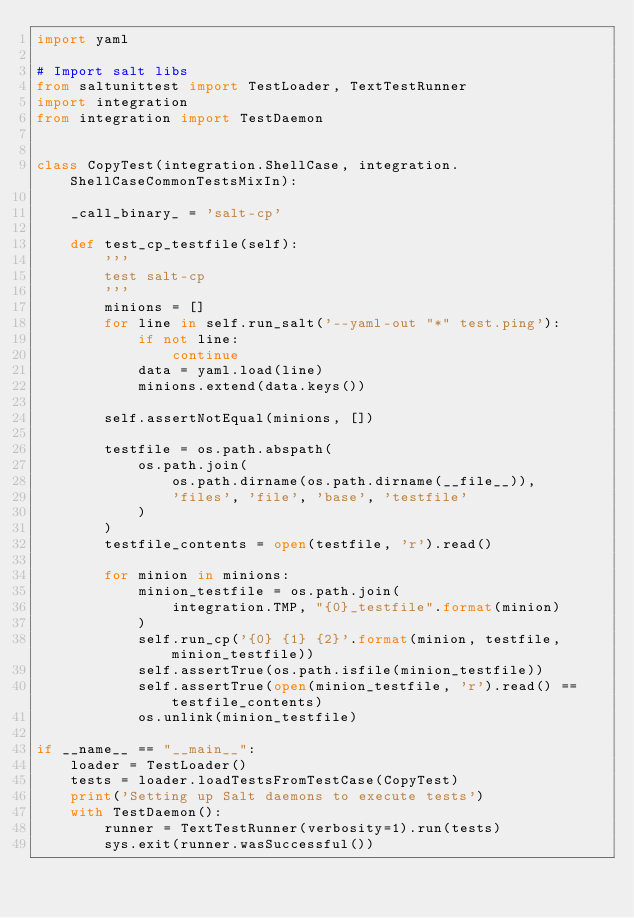<code> <loc_0><loc_0><loc_500><loc_500><_Python_>import yaml

# Import salt libs
from saltunittest import TestLoader, TextTestRunner
import integration
from integration import TestDaemon


class CopyTest(integration.ShellCase, integration.ShellCaseCommonTestsMixIn):

    _call_binary_ = 'salt-cp'

    def test_cp_testfile(self):
        '''
        test salt-cp
        '''
        minions = []
        for line in self.run_salt('--yaml-out "*" test.ping'):
            if not line:
                continue
            data = yaml.load(line)
            minions.extend(data.keys())

        self.assertNotEqual(minions, [])

        testfile = os.path.abspath(
            os.path.join(
                os.path.dirname(os.path.dirname(__file__)),
                'files', 'file', 'base', 'testfile'
            )
        )
        testfile_contents = open(testfile, 'r').read()

        for minion in minions:
            minion_testfile = os.path.join(
                integration.TMP, "{0}_testfile".format(minion)
            )
            self.run_cp('{0} {1} {2}'.format(minion, testfile, minion_testfile))
            self.assertTrue(os.path.isfile(minion_testfile))
            self.assertTrue(open(minion_testfile, 'r').read() == testfile_contents)
            os.unlink(minion_testfile)

if __name__ == "__main__":
    loader = TestLoader()
    tests = loader.loadTestsFromTestCase(CopyTest)
    print('Setting up Salt daemons to execute tests')
    with TestDaemon():
        runner = TextTestRunner(verbosity=1).run(tests)
        sys.exit(runner.wasSuccessful())
</code> 